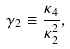<formula> <loc_0><loc_0><loc_500><loc_500>\gamma _ { 2 } \equiv \frac { \kappa _ { 4 } } { \kappa _ { 2 } ^ { 2 } } ,</formula> 